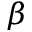<formula> <loc_0><loc_0><loc_500><loc_500>\beta</formula> 